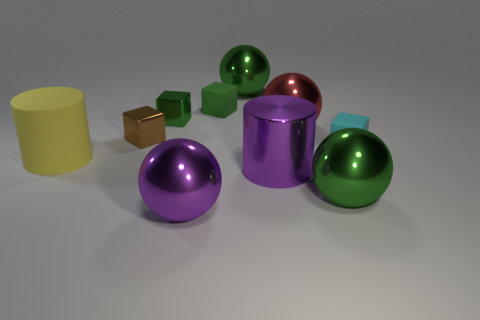What number of big objects have the same color as the big metal cylinder? There is 1 other big object that shares the same shade of purple as the big metal cylinder, which is the big sphere on the left. 